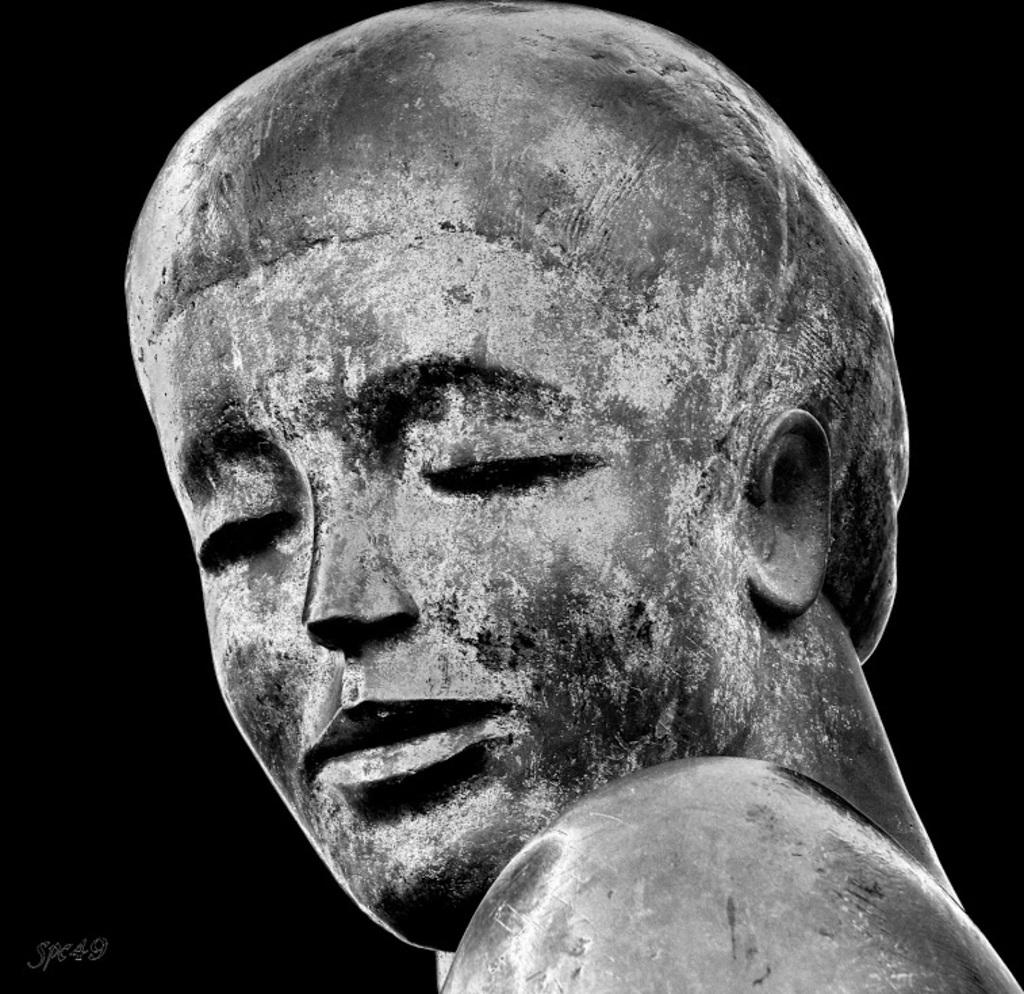What is the main subject of the image? The main subject of the image is a statue of a human. What material is the statue made of? The statue appears to be made of stone. How was the statue created? The statue is a carving. Is there any additional information or markings in the image? Yes, there is a watermark in the bottom left corner of the image. What type of boundary is depicted in the image? There is no boundary depicted in the image; it features a statue of a human. How does the brake system work in the statue? The statue does not have a brake system, as it is a stationary carving. 